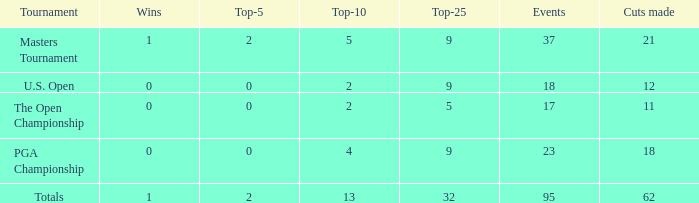In the top 10, what is the count of wins surpassing 13? None. Could you parse the entire table as a dict? {'header': ['Tournament', 'Wins', 'Top-5', 'Top-10', 'Top-25', 'Events', 'Cuts made'], 'rows': [['Masters Tournament', '1', '2', '5', '9', '37', '21'], ['U.S. Open', '0', '0', '2', '9', '18', '12'], ['The Open Championship', '0', '0', '2', '5', '17', '11'], ['PGA Championship', '0', '0', '4', '9', '23', '18'], ['Totals', '1', '2', '13', '32', '95', '62']]} 